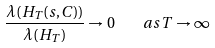<formula> <loc_0><loc_0><loc_500><loc_500>\frac { \lambda ( H _ { T } ( s , C ) ) } { \lambda ( H _ { T } ) } \to 0 \quad a s \, T \to \infty</formula> 